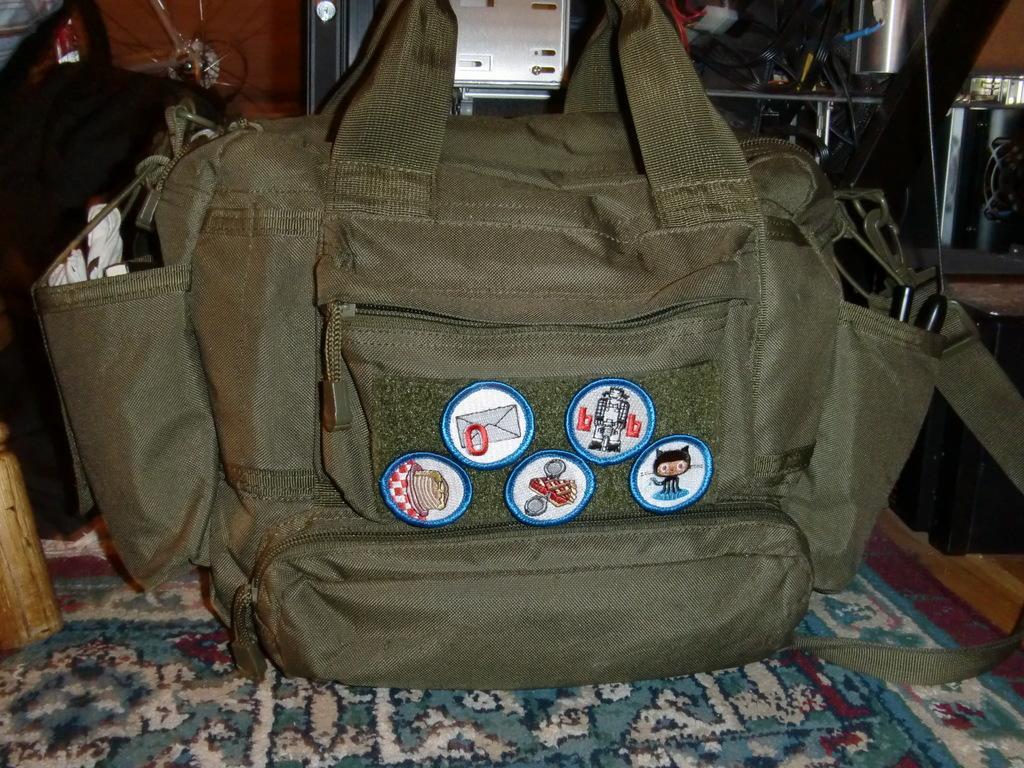Could you give a brief overview of what you see in this image? We can see bag on the carpet. 